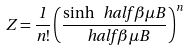Convert formula to latex. <formula><loc_0><loc_0><loc_500><loc_500>Z = \frac { 1 } { n ! } \left ( \frac { \sinh { \ h a l f \beta \mu B } } { \ h a l f \beta \mu B } \right ) ^ { n }</formula> 